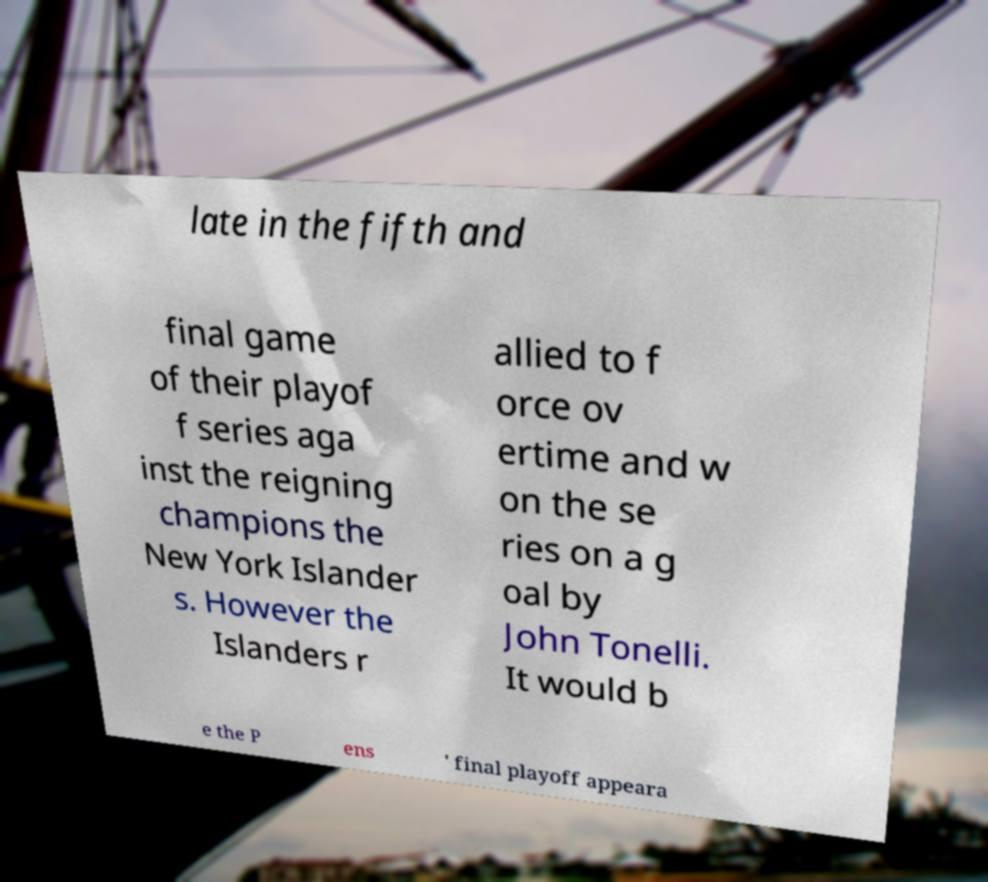Could you assist in decoding the text presented in this image and type it out clearly? late in the fifth and final game of their playof f series aga inst the reigning champions the New York Islander s. However the Islanders r allied to f orce ov ertime and w on the se ries on a g oal by John Tonelli. It would b e the P ens ' final playoff appeara 